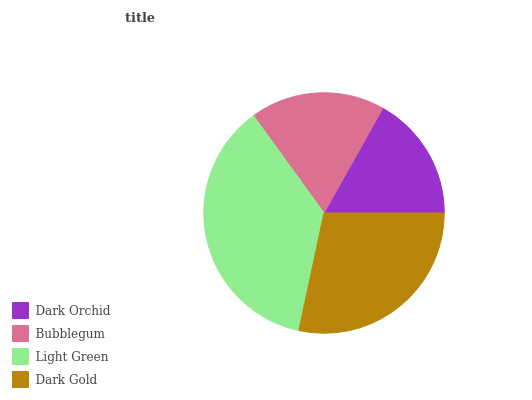Is Dark Orchid the minimum?
Answer yes or no. Yes. Is Light Green the maximum?
Answer yes or no. Yes. Is Bubblegum the minimum?
Answer yes or no. No. Is Bubblegum the maximum?
Answer yes or no. No. Is Bubblegum greater than Dark Orchid?
Answer yes or no. Yes. Is Dark Orchid less than Bubblegum?
Answer yes or no. Yes. Is Dark Orchid greater than Bubblegum?
Answer yes or no. No. Is Bubblegum less than Dark Orchid?
Answer yes or no. No. Is Dark Gold the high median?
Answer yes or no. Yes. Is Bubblegum the low median?
Answer yes or no. Yes. Is Dark Orchid the high median?
Answer yes or no. No. Is Dark Gold the low median?
Answer yes or no. No. 